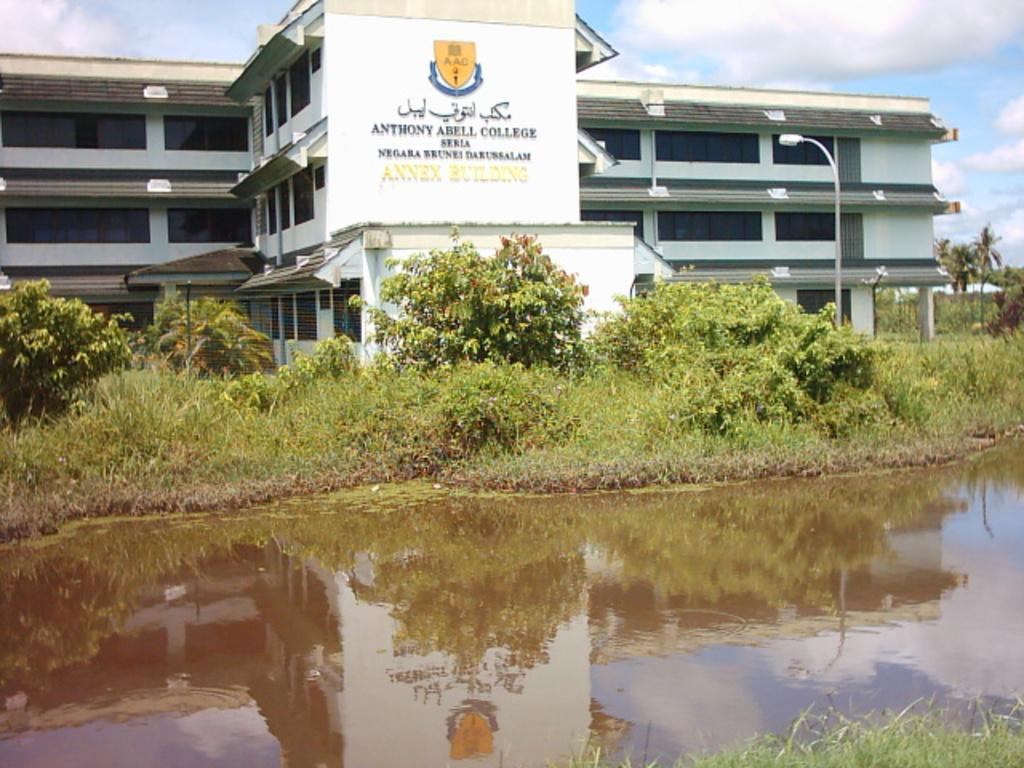<image>
Share a concise interpretation of the image provided. The college behind the river is called the Anthony Abell College. 